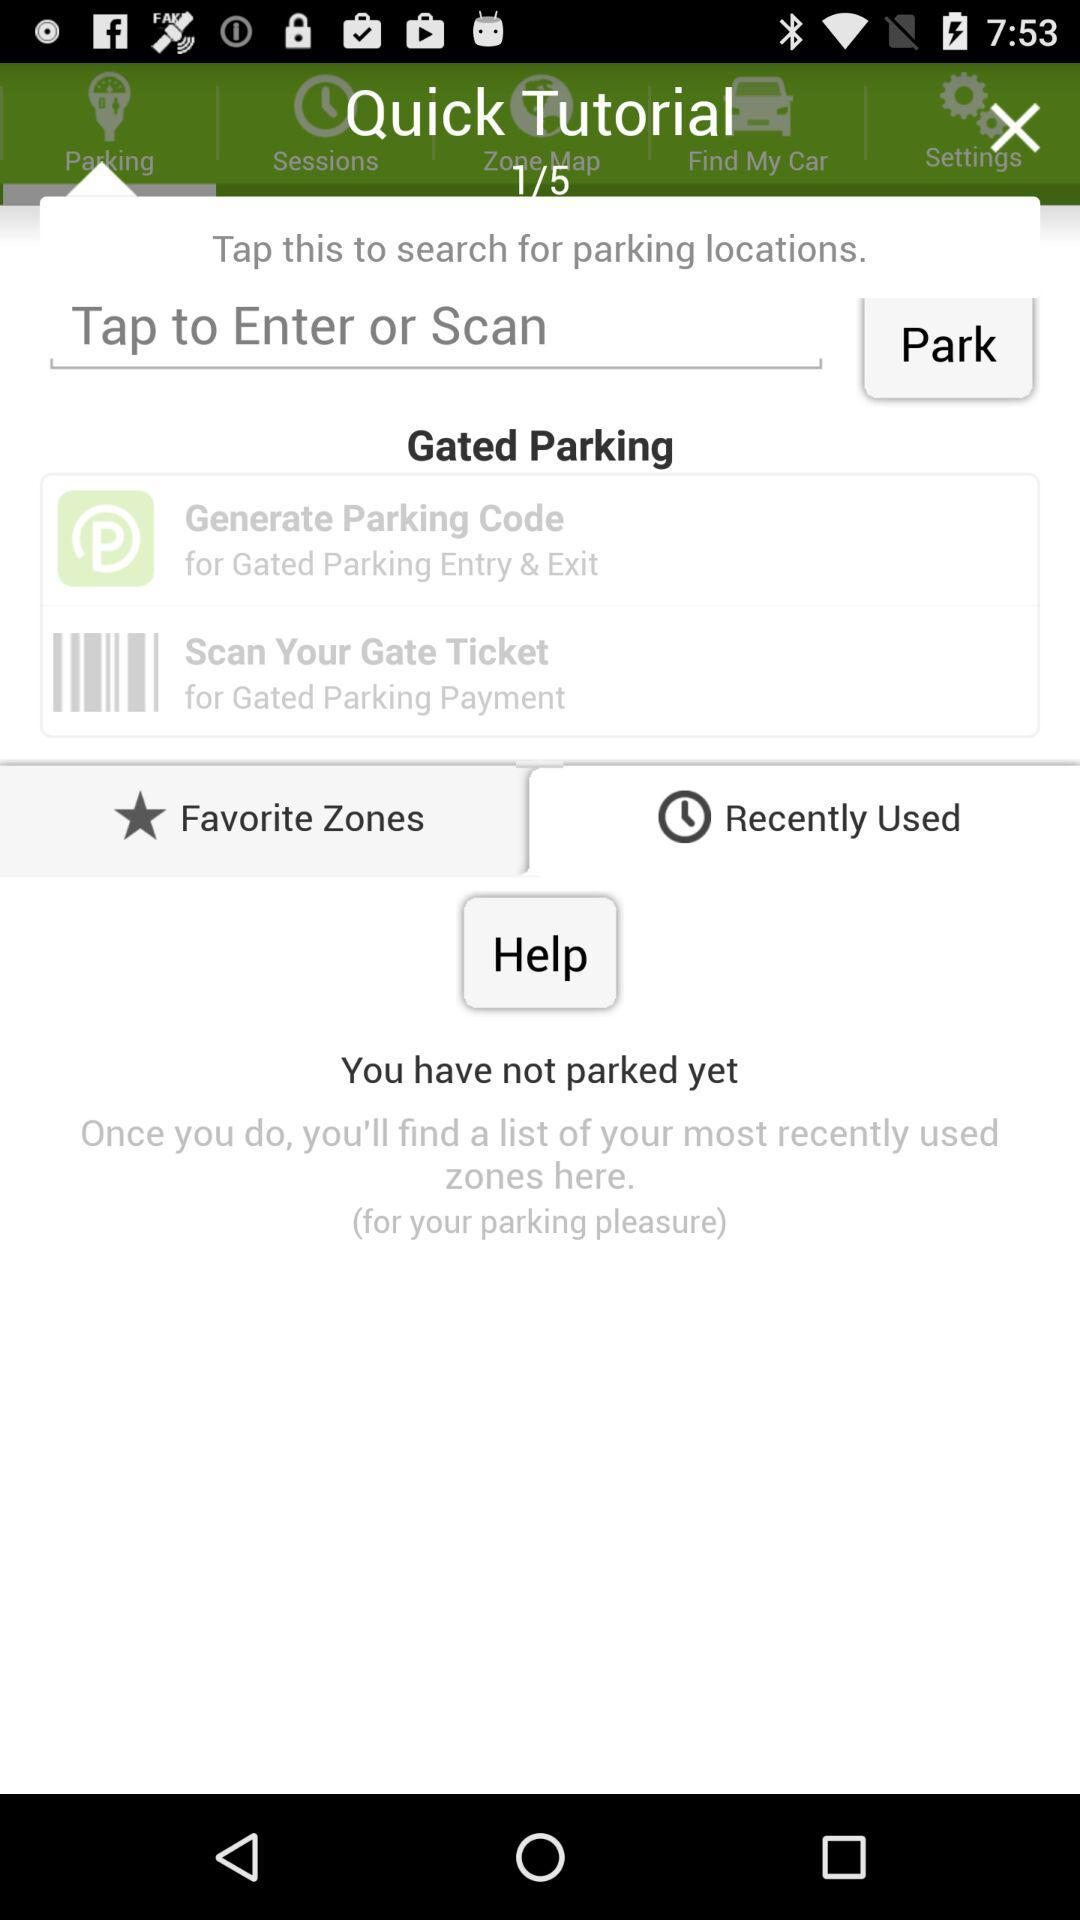At what tutorial am I? You are on tutorial 1. 